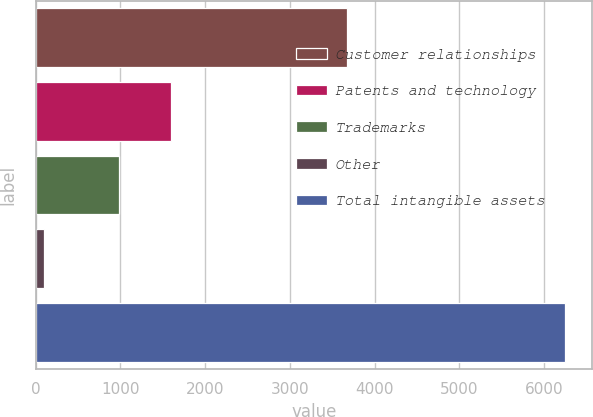Convert chart. <chart><loc_0><loc_0><loc_500><loc_500><bar_chart><fcel>Customer relationships<fcel>Patents and technology<fcel>Trademarks<fcel>Other<fcel>Total intangible assets<nl><fcel>3674<fcel>1594.8<fcel>980<fcel>103<fcel>6251<nl></chart> 